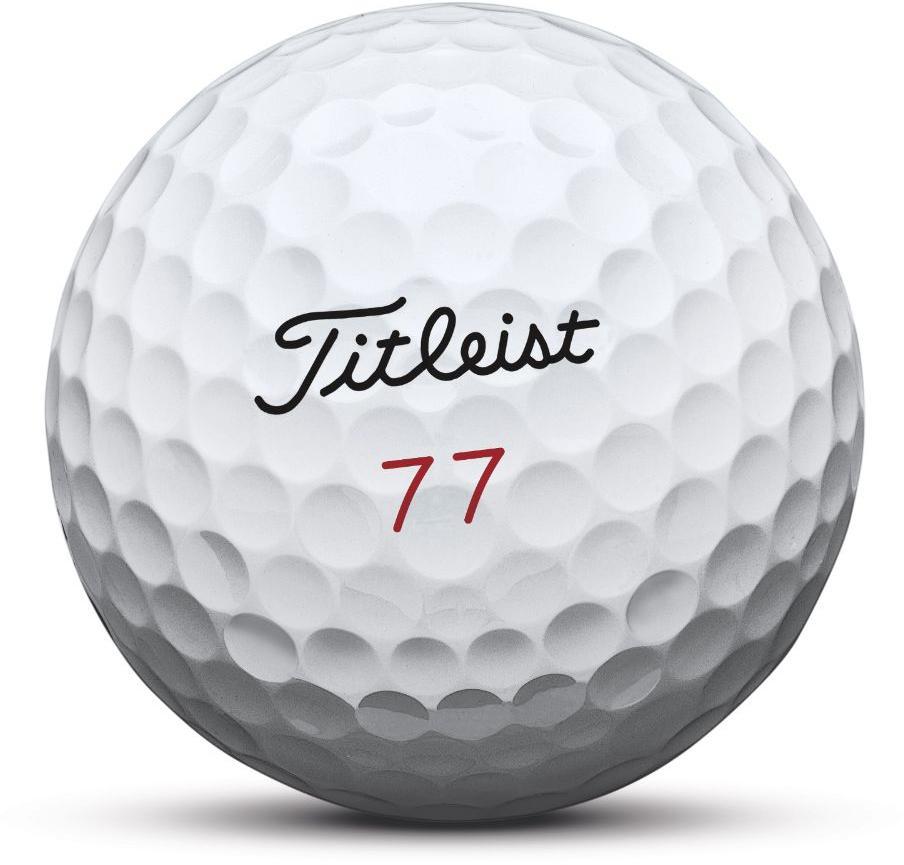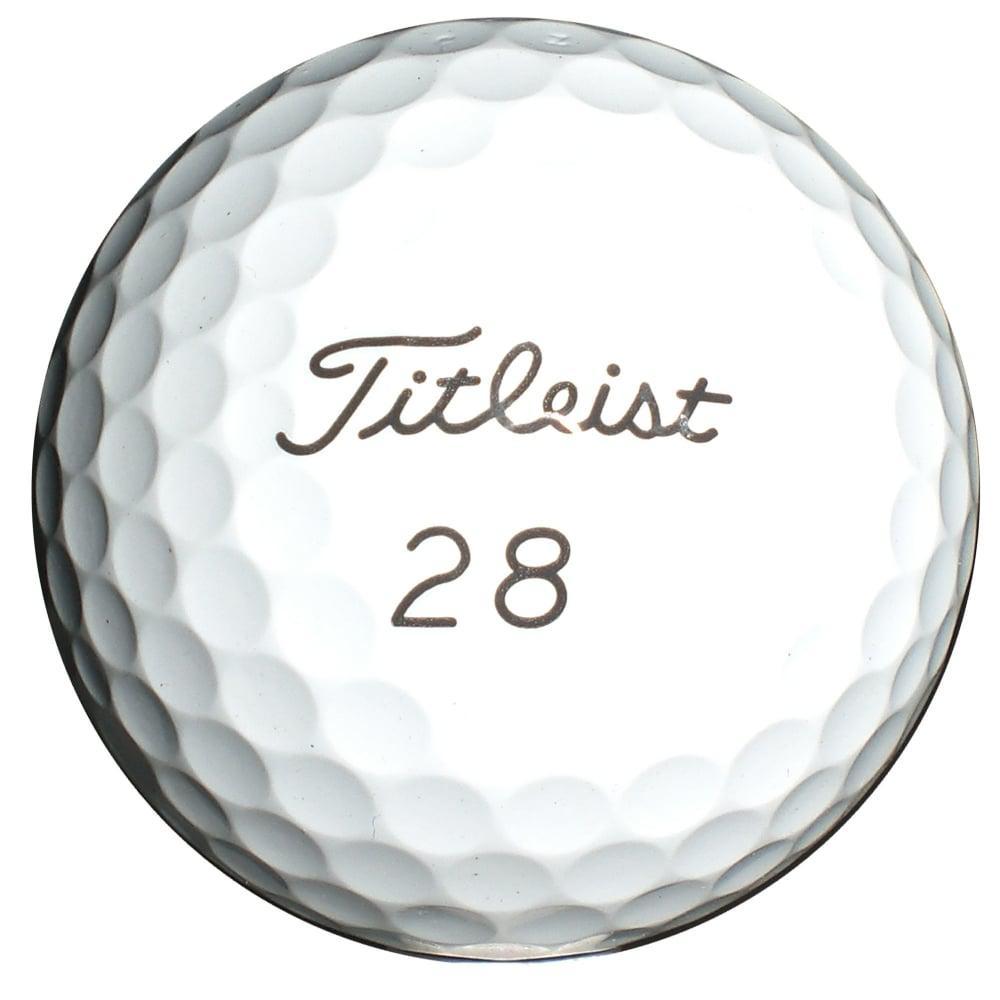The first image is the image on the left, the second image is the image on the right. For the images displayed, is the sentence "At least one image has exactly one golf ball." factually correct? Answer yes or no. Yes. The first image is the image on the left, the second image is the image on the right. Examine the images to the left and right. Is the description "Only one golf ball is depicted on at least one image." accurate? Answer yes or no. Yes. 